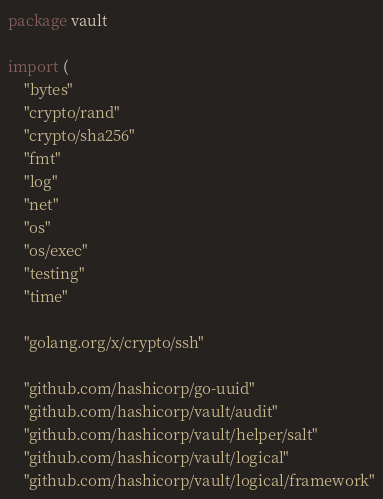<code> <loc_0><loc_0><loc_500><loc_500><_Go_>package vault

import (
	"bytes"
	"crypto/rand"
	"crypto/sha256"
	"fmt"
	"log"
	"net"
	"os"
	"os/exec"
	"testing"
	"time"

	"golang.org/x/crypto/ssh"

	"github.com/hashicorp/go-uuid"
	"github.com/hashicorp/vault/audit"
	"github.com/hashicorp/vault/helper/salt"
	"github.com/hashicorp/vault/logical"
	"github.com/hashicorp/vault/logical/framework"</code> 